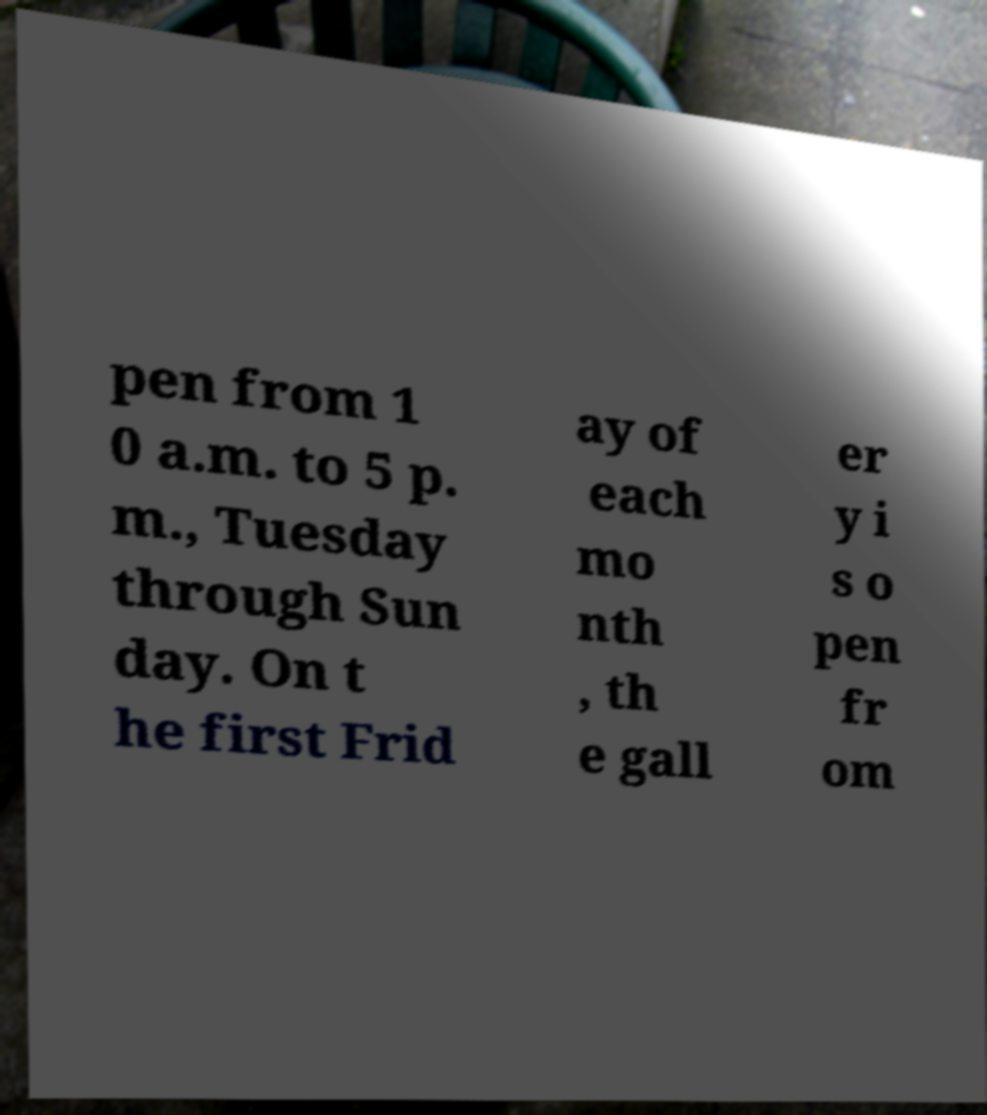Could you assist in decoding the text presented in this image and type it out clearly? pen from 1 0 a.m. to 5 p. m., Tuesday through Sun day. On t he first Frid ay of each mo nth , th e gall er y i s o pen fr om 